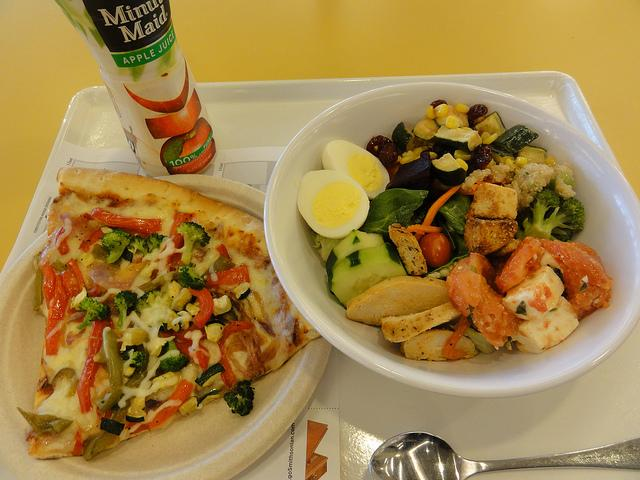What type of red sliced topping is on the pizza? pepper 